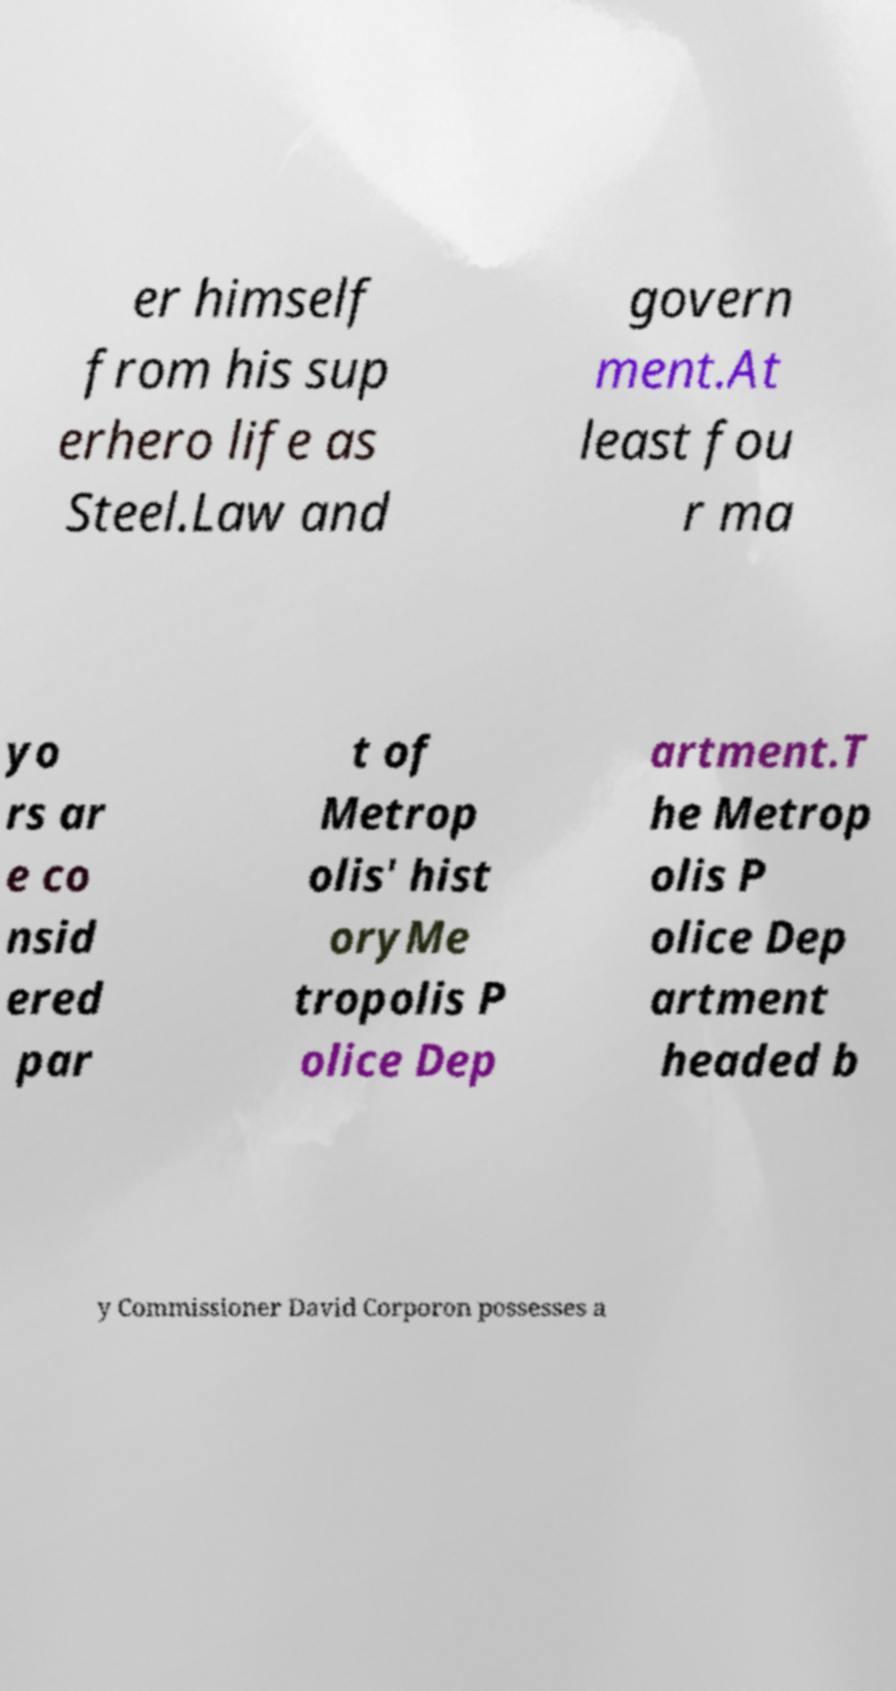Please read and relay the text visible in this image. What does it say? er himself from his sup erhero life as Steel.Law and govern ment.At least fou r ma yo rs ar e co nsid ered par t of Metrop olis' hist oryMe tropolis P olice Dep artment.T he Metrop olis P olice Dep artment headed b y Commissioner David Corporon possesses a 